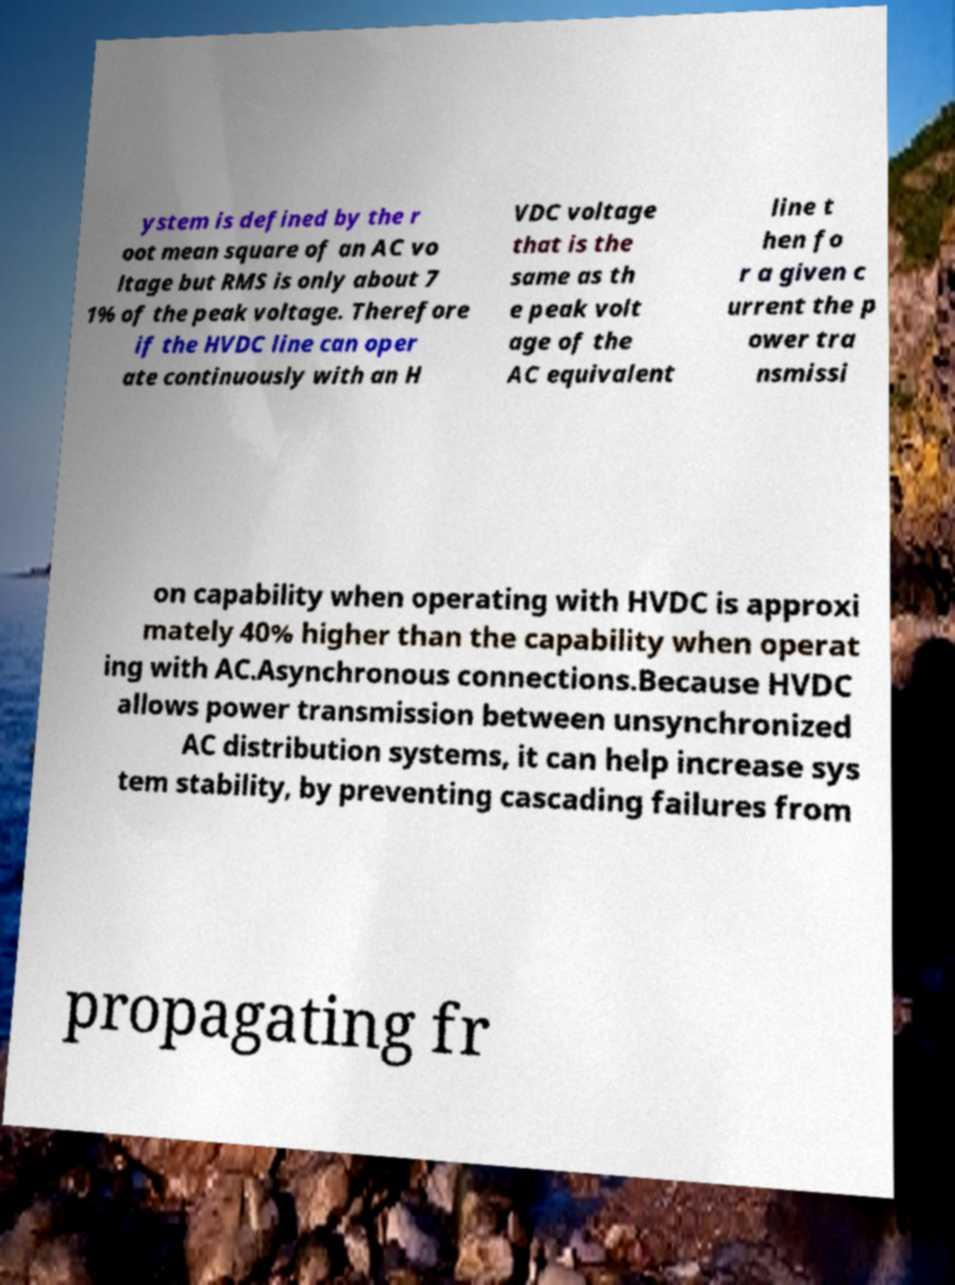What messages or text are displayed in this image? I need them in a readable, typed format. ystem is defined by the r oot mean square of an AC vo ltage but RMS is only about 7 1% of the peak voltage. Therefore if the HVDC line can oper ate continuously with an H VDC voltage that is the same as th e peak volt age of the AC equivalent line t hen fo r a given c urrent the p ower tra nsmissi on capability when operating with HVDC is approxi mately 40% higher than the capability when operat ing with AC.Asynchronous connections.Because HVDC allows power transmission between unsynchronized AC distribution systems, it can help increase sys tem stability, by preventing cascading failures from propagating fr 